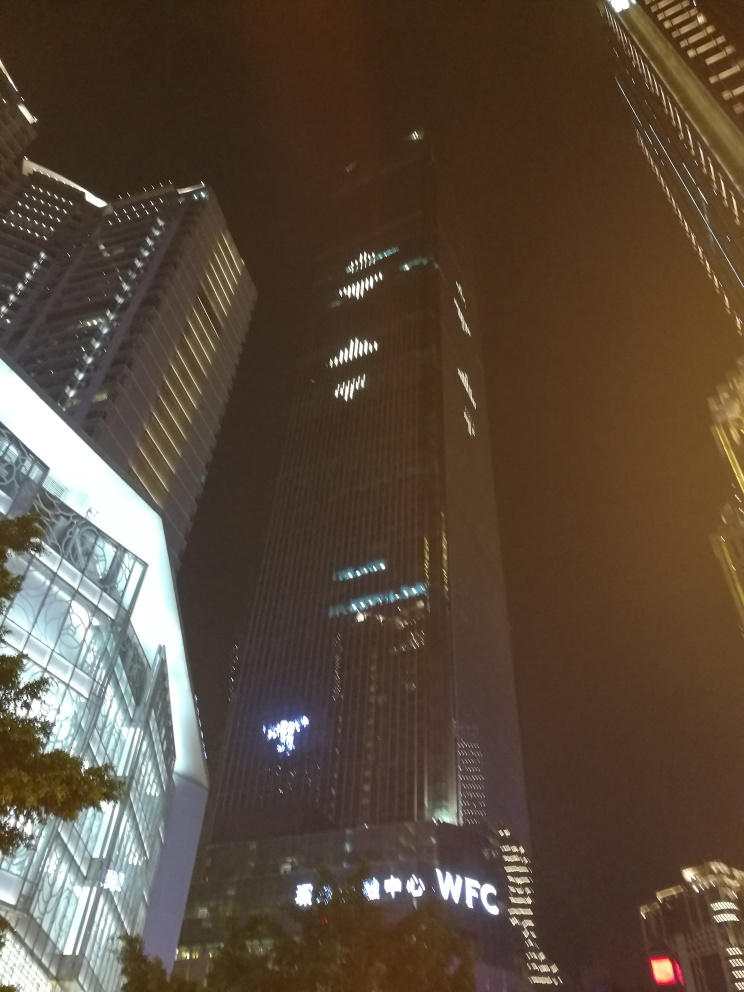Are the colors in the image monotonous? While the image predominantly showcases shades of dark blue and black due to the night sky and the silhouettes of the buildings, there are also contrasting elements of light such as the illuminated windows and the lit signage which add some variety to the color palette. Therefore, the colors are not entirely monotonous; there is a play of light and darkness that creates a visual contrast. 